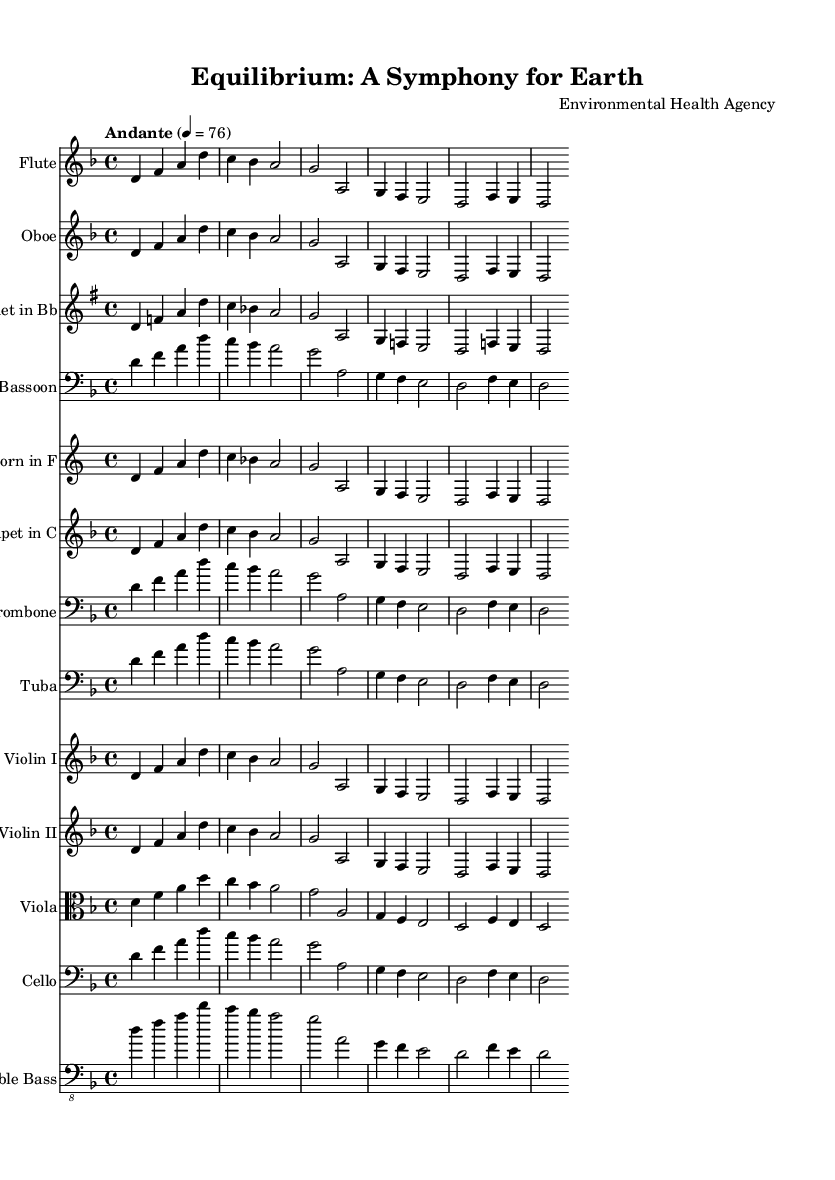What is the key signature of this music? The key signature indicates the presence of one flat (B flat). Hence, the key is D minor, which consists of the notes D, E, F, G, A, B flat, and C.
Answer: D minor What is the time signature of this music? The time signature, displayed as "4/4," indicates there are four beats in each measure, with a quarter note receiving one beat.
Answer: 4/4 What is the tempo marking of this music? The tempo marking "Andante" suggests a moderate walking pace, which is typically between 76-108 beats per minute. The specific marking indicates 76 BPM.
Answer: Andante How many instruments are used in this symphony? By counting the staves listed in the score, there are twelve different instruments, representing various orchestral families including woodwinds, brass, and strings.
Answer: Twelve Which themes are represented in this symphony? The themes are denoted as "themeA" and "themeB," which are musical motifs used throughout the symphony. These serve as foundational ideas for composition and development.
Answer: themeA and themeB What is the instrumentation for the brass section? The brass section includes Horn in F, Trumpet in C, Trombone, and Tuba. Each is represented by a separate staff in the score for clarity and performance.
Answer: Horn in F, Trumpet in C, Trombone, Tuba Based on the overall structure, what genre does this piece belong to? The overall large-scale structure, orchestration, and thematic development categorize this work as a symphony, which is a complex orchestral piece often in multiple movements.
Answer: Symphony 